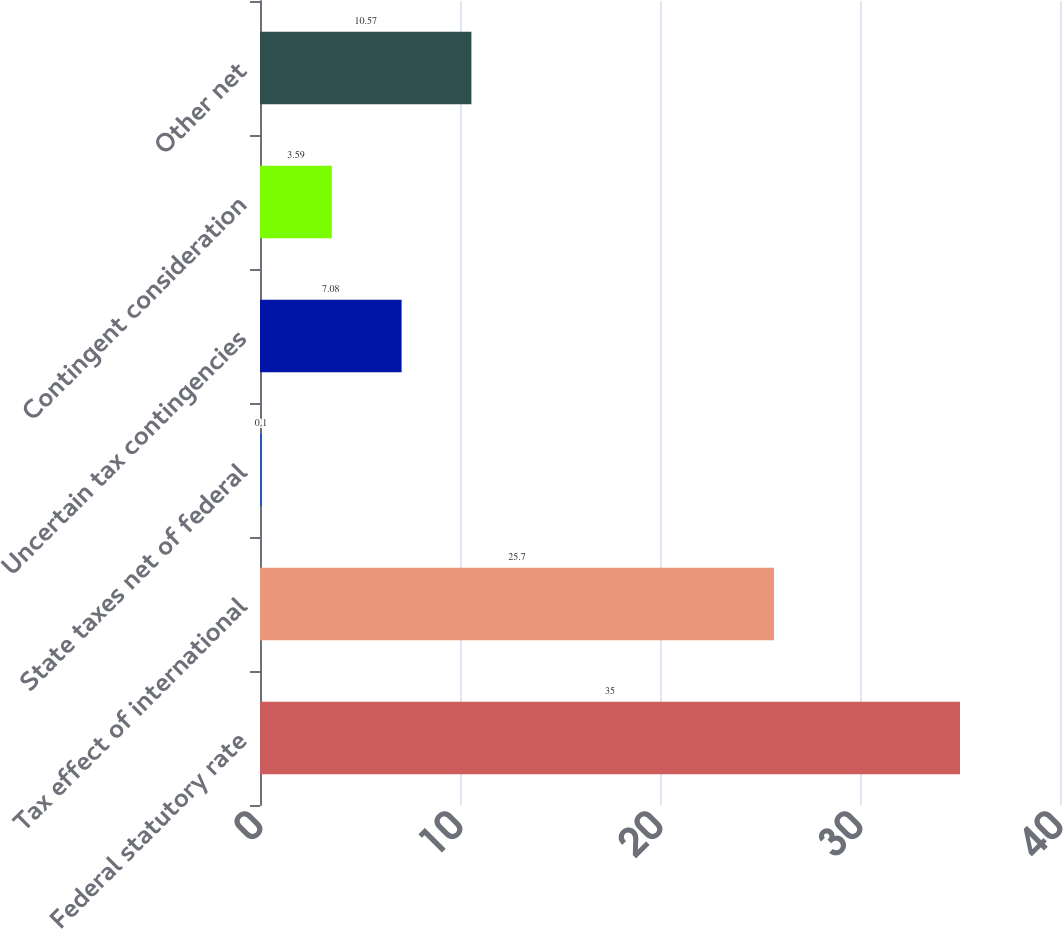Convert chart. <chart><loc_0><loc_0><loc_500><loc_500><bar_chart><fcel>Federal statutory rate<fcel>Tax effect of international<fcel>State taxes net of federal<fcel>Uncertain tax contingencies<fcel>Contingent consideration<fcel>Other net<nl><fcel>35<fcel>25.7<fcel>0.1<fcel>7.08<fcel>3.59<fcel>10.57<nl></chart> 